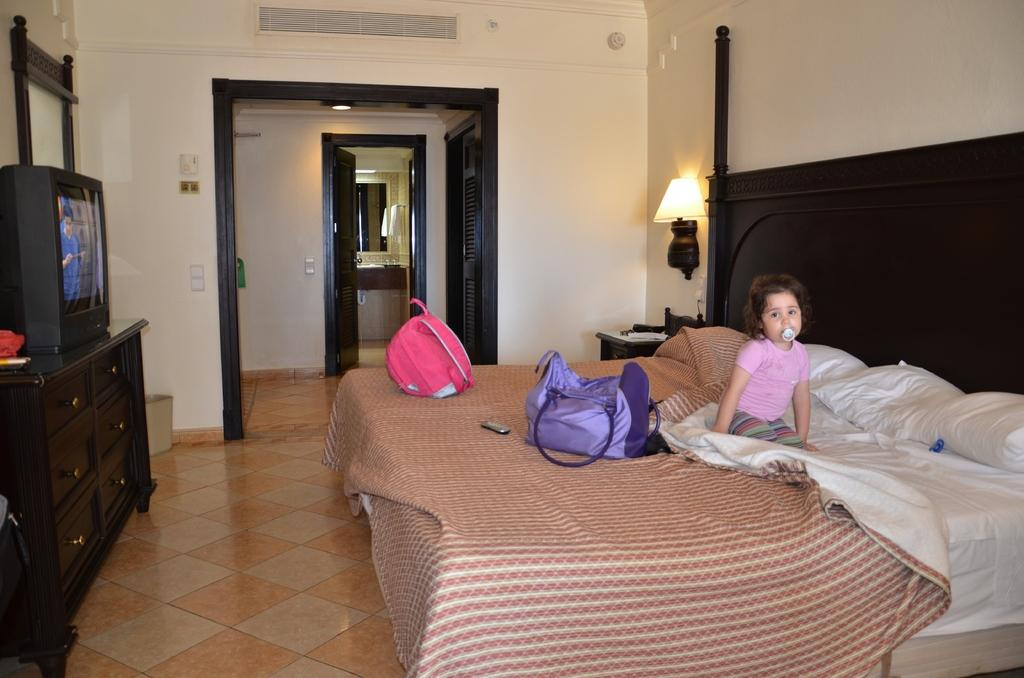What is the girl doing in the image? The girl is sitting on the bed. What is covering the bed in the image? There is a blanket on the bed, and there are also pillows on the bed. What objects can be seen in the image besides the bed and the girl? There are bags and a television in the image. Where is the television located in the image? The television is on the right side of the image. What type of crops is the farmer harvesting in the field in the image? There is no farmer or field present in the image; it features a girl sitting on a bed with a blanket, pillows, bags, and a television. 